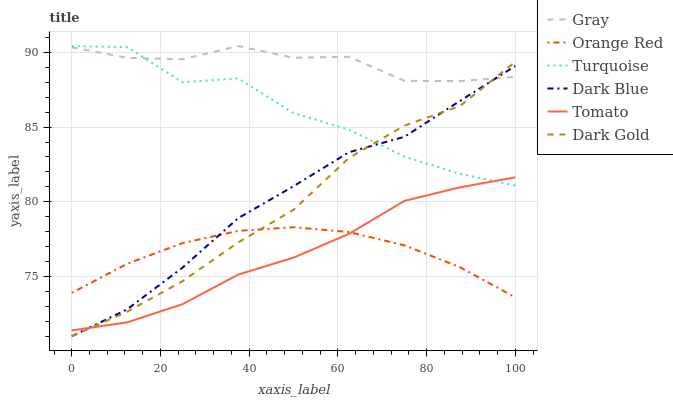Does Tomato have the minimum area under the curve?
Answer yes or no. Yes. Does Gray have the maximum area under the curve?
Answer yes or no. Yes. Does Turquoise have the minimum area under the curve?
Answer yes or no. No. Does Turquoise have the maximum area under the curve?
Answer yes or no. No. Is Orange Red the smoothest?
Answer yes or no. Yes. Is Turquoise the roughest?
Answer yes or no. Yes. Is Gray the smoothest?
Answer yes or no. No. Is Gray the roughest?
Answer yes or no. No. Does Dark Gold have the lowest value?
Answer yes or no. Yes. Does Turquoise have the lowest value?
Answer yes or no. No. Does Turquoise have the highest value?
Answer yes or no. Yes. Does Gray have the highest value?
Answer yes or no. No. Is Orange Red less than Gray?
Answer yes or no. Yes. Is Turquoise greater than Orange Red?
Answer yes or no. Yes. Does Orange Red intersect Dark Gold?
Answer yes or no. Yes. Is Orange Red less than Dark Gold?
Answer yes or no. No. Is Orange Red greater than Dark Gold?
Answer yes or no. No. Does Orange Red intersect Gray?
Answer yes or no. No. 